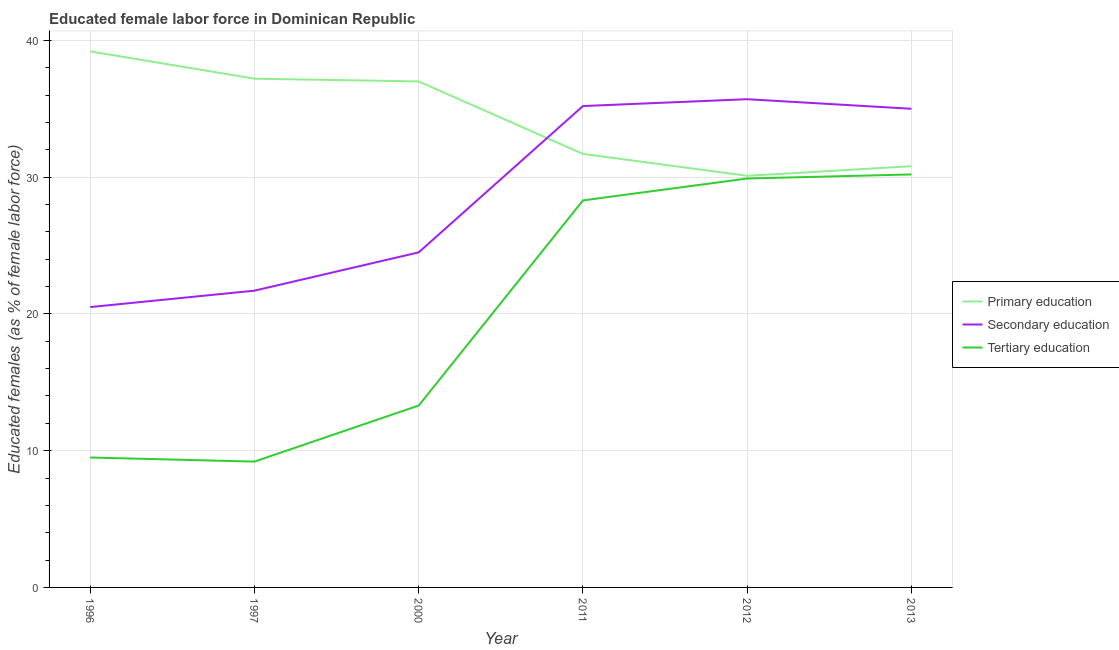How many different coloured lines are there?
Keep it short and to the point. 3. Does the line corresponding to percentage of female labor force who received secondary education intersect with the line corresponding to percentage of female labor force who received tertiary education?
Make the answer very short. No. What is the percentage of female labor force who received primary education in 1996?
Offer a terse response. 39.2. Across all years, what is the maximum percentage of female labor force who received tertiary education?
Make the answer very short. 30.2. Across all years, what is the minimum percentage of female labor force who received tertiary education?
Provide a succinct answer. 9.2. In which year was the percentage of female labor force who received tertiary education maximum?
Make the answer very short. 2013. In which year was the percentage of female labor force who received primary education minimum?
Ensure brevity in your answer.  2012. What is the total percentage of female labor force who received primary education in the graph?
Offer a terse response. 206. What is the difference between the percentage of female labor force who received secondary education in 1997 and that in 2000?
Your response must be concise. -2.8. What is the difference between the percentage of female labor force who received primary education in 2011 and the percentage of female labor force who received tertiary education in 2000?
Provide a succinct answer. 18.4. What is the average percentage of female labor force who received primary education per year?
Your answer should be compact. 34.33. In the year 2011, what is the difference between the percentage of female labor force who received tertiary education and percentage of female labor force who received secondary education?
Provide a short and direct response. -6.9. What is the ratio of the percentage of female labor force who received secondary education in 2011 to that in 2012?
Your answer should be compact. 0.99. Is the percentage of female labor force who received secondary education in 1997 less than that in 2011?
Make the answer very short. Yes. What is the difference between the highest and the second highest percentage of female labor force who received tertiary education?
Ensure brevity in your answer.  0.3. What is the difference between the highest and the lowest percentage of female labor force who received primary education?
Give a very brief answer. 9.1. In how many years, is the percentage of female labor force who received tertiary education greater than the average percentage of female labor force who received tertiary education taken over all years?
Provide a succinct answer. 3. Is the sum of the percentage of female labor force who received tertiary education in 1997 and 2000 greater than the maximum percentage of female labor force who received primary education across all years?
Your answer should be compact. No. Is it the case that in every year, the sum of the percentage of female labor force who received primary education and percentage of female labor force who received secondary education is greater than the percentage of female labor force who received tertiary education?
Give a very brief answer. Yes. Does the percentage of female labor force who received secondary education monotonically increase over the years?
Provide a succinct answer. No. Is the percentage of female labor force who received primary education strictly greater than the percentage of female labor force who received secondary education over the years?
Make the answer very short. No. Is the percentage of female labor force who received primary education strictly less than the percentage of female labor force who received tertiary education over the years?
Your answer should be very brief. No. What is the difference between two consecutive major ticks on the Y-axis?
Offer a terse response. 10. Are the values on the major ticks of Y-axis written in scientific E-notation?
Your response must be concise. No. Where does the legend appear in the graph?
Keep it short and to the point. Center right. What is the title of the graph?
Offer a very short reply. Educated female labor force in Dominican Republic. Does "Domestic" appear as one of the legend labels in the graph?
Give a very brief answer. No. What is the label or title of the Y-axis?
Keep it short and to the point. Educated females (as % of female labor force). What is the Educated females (as % of female labor force) of Primary education in 1996?
Your answer should be very brief. 39.2. What is the Educated females (as % of female labor force) in Primary education in 1997?
Give a very brief answer. 37.2. What is the Educated females (as % of female labor force) of Secondary education in 1997?
Offer a very short reply. 21.7. What is the Educated females (as % of female labor force) in Tertiary education in 1997?
Ensure brevity in your answer.  9.2. What is the Educated females (as % of female labor force) in Secondary education in 2000?
Keep it short and to the point. 24.5. What is the Educated females (as % of female labor force) in Tertiary education in 2000?
Your answer should be very brief. 13.3. What is the Educated females (as % of female labor force) in Primary education in 2011?
Your answer should be very brief. 31.7. What is the Educated females (as % of female labor force) in Secondary education in 2011?
Offer a terse response. 35.2. What is the Educated females (as % of female labor force) in Tertiary education in 2011?
Offer a very short reply. 28.3. What is the Educated females (as % of female labor force) in Primary education in 2012?
Make the answer very short. 30.1. What is the Educated females (as % of female labor force) of Secondary education in 2012?
Offer a very short reply. 35.7. What is the Educated females (as % of female labor force) of Tertiary education in 2012?
Provide a short and direct response. 29.9. What is the Educated females (as % of female labor force) of Primary education in 2013?
Offer a very short reply. 30.8. What is the Educated females (as % of female labor force) in Secondary education in 2013?
Your answer should be very brief. 35. What is the Educated females (as % of female labor force) of Tertiary education in 2013?
Your answer should be compact. 30.2. Across all years, what is the maximum Educated females (as % of female labor force) in Primary education?
Provide a short and direct response. 39.2. Across all years, what is the maximum Educated females (as % of female labor force) in Secondary education?
Offer a terse response. 35.7. Across all years, what is the maximum Educated females (as % of female labor force) in Tertiary education?
Offer a very short reply. 30.2. Across all years, what is the minimum Educated females (as % of female labor force) in Primary education?
Offer a very short reply. 30.1. Across all years, what is the minimum Educated females (as % of female labor force) in Tertiary education?
Provide a succinct answer. 9.2. What is the total Educated females (as % of female labor force) of Primary education in the graph?
Make the answer very short. 206. What is the total Educated females (as % of female labor force) in Secondary education in the graph?
Provide a succinct answer. 172.6. What is the total Educated females (as % of female labor force) of Tertiary education in the graph?
Make the answer very short. 120.4. What is the difference between the Educated females (as % of female labor force) in Primary education in 1996 and that in 1997?
Keep it short and to the point. 2. What is the difference between the Educated females (as % of female labor force) of Secondary education in 1996 and that in 1997?
Provide a succinct answer. -1.2. What is the difference between the Educated females (as % of female labor force) of Primary education in 1996 and that in 2011?
Keep it short and to the point. 7.5. What is the difference between the Educated females (as % of female labor force) of Secondary education in 1996 and that in 2011?
Your answer should be very brief. -14.7. What is the difference between the Educated females (as % of female labor force) of Tertiary education in 1996 and that in 2011?
Provide a succinct answer. -18.8. What is the difference between the Educated females (as % of female labor force) in Secondary education in 1996 and that in 2012?
Offer a terse response. -15.2. What is the difference between the Educated females (as % of female labor force) in Tertiary education in 1996 and that in 2012?
Give a very brief answer. -20.4. What is the difference between the Educated females (as % of female labor force) in Secondary education in 1996 and that in 2013?
Give a very brief answer. -14.5. What is the difference between the Educated females (as % of female labor force) of Tertiary education in 1996 and that in 2013?
Provide a short and direct response. -20.7. What is the difference between the Educated females (as % of female labor force) of Primary education in 1997 and that in 2000?
Provide a short and direct response. 0.2. What is the difference between the Educated females (as % of female labor force) in Secondary education in 1997 and that in 2011?
Provide a short and direct response. -13.5. What is the difference between the Educated females (as % of female labor force) in Tertiary education in 1997 and that in 2011?
Your answer should be compact. -19.1. What is the difference between the Educated females (as % of female labor force) in Secondary education in 1997 and that in 2012?
Offer a very short reply. -14. What is the difference between the Educated females (as % of female labor force) of Tertiary education in 1997 and that in 2012?
Your answer should be very brief. -20.7. What is the difference between the Educated females (as % of female labor force) of Tertiary education in 1997 and that in 2013?
Give a very brief answer. -21. What is the difference between the Educated females (as % of female labor force) in Secondary education in 2000 and that in 2012?
Give a very brief answer. -11.2. What is the difference between the Educated females (as % of female labor force) in Tertiary education in 2000 and that in 2012?
Your answer should be very brief. -16.6. What is the difference between the Educated females (as % of female labor force) in Tertiary education in 2000 and that in 2013?
Provide a short and direct response. -16.9. What is the difference between the Educated females (as % of female labor force) in Secondary education in 2011 and that in 2012?
Your answer should be compact. -0.5. What is the difference between the Educated females (as % of female labor force) in Tertiary education in 2011 and that in 2012?
Provide a short and direct response. -1.6. What is the difference between the Educated females (as % of female labor force) in Tertiary education in 2011 and that in 2013?
Your answer should be compact. -1.9. What is the difference between the Educated females (as % of female labor force) in Primary education in 2012 and that in 2013?
Provide a short and direct response. -0.7. What is the difference between the Educated females (as % of female labor force) in Tertiary education in 2012 and that in 2013?
Provide a succinct answer. -0.3. What is the difference between the Educated females (as % of female labor force) in Primary education in 1996 and the Educated females (as % of female labor force) in Tertiary education in 2000?
Your answer should be compact. 25.9. What is the difference between the Educated females (as % of female labor force) in Secondary education in 1996 and the Educated females (as % of female labor force) in Tertiary education in 2000?
Provide a succinct answer. 7.2. What is the difference between the Educated females (as % of female labor force) of Primary education in 1996 and the Educated females (as % of female labor force) of Secondary education in 2011?
Your answer should be compact. 4. What is the difference between the Educated females (as % of female labor force) in Primary education in 1996 and the Educated females (as % of female labor force) in Tertiary education in 2011?
Make the answer very short. 10.9. What is the difference between the Educated females (as % of female labor force) in Secondary education in 1996 and the Educated females (as % of female labor force) in Tertiary education in 2011?
Give a very brief answer. -7.8. What is the difference between the Educated females (as % of female labor force) of Primary education in 1996 and the Educated females (as % of female labor force) of Secondary education in 2012?
Your response must be concise. 3.5. What is the difference between the Educated females (as % of female labor force) of Primary education in 1996 and the Educated females (as % of female labor force) of Secondary education in 2013?
Your answer should be compact. 4.2. What is the difference between the Educated females (as % of female labor force) of Secondary education in 1996 and the Educated females (as % of female labor force) of Tertiary education in 2013?
Make the answer very short. -9.7. What is the difference between the Educated females (as % of female labor force) of Primary education in 1997 and the Educated females (as % of female labor force) of Tertiary education in 2000?
Ensure brevity in your answer.  23.9. What is the difference between the Educated females (as % of female labor force) in Primary education in 1997 and the Educated females (as % of female labor force) in Secondary education in 2011?
Your response must be concise. 2. What is the difference between the Educated females (as % of female labor force) in Primary education in 1997 and the Educated females (as % of female labor force) in Tertiary education in 2012?
Your answer should be very brief. 7.3. What is the difference between the Educated females (as % of female labor force) of Secondary education in 1997 and the Educated females (as % of female labor force) of Tertiary education in 2012?
Your answer should be very brief. -8.2. What is the difference between the Educated females (as % of female labor force) in Primary education in 1997 and the Educated females (as % of female labor force) in Secondary education in 2013?
Offer a very short reply. 2.2. What is the difference between the Educated females (as % of female labor force) in Primary education in 1997 and the Educated females (as % of female labor force) in Tertiary education in 2013?
Keep it short and to the point. 7. What is the difference between the Educated females (as % of female labor force) of Primary education in 2000 and the Educated females (as % of female labor force) of Secondary education in 2012?
Offer a terse response. 1.3. What is the difference between the Educated females (as % of female labor force) of Primary education in 2000 and the Educated females (as % of female labor force) of Tertiary education in 2012?
Your answer should be very brief. 7.1. What is the difference between the Educated females (as % of female labor force) in Primary education in 2000 and the Educated females (as % of female labor force) in Secondary education in 2013?
Give a very brief answer. 2. What is the difference between the Educated females (as % of female labor force) of Secondary education in 2000 and the Educated females (as % of female labor force) of Tertiary education in 2013?
Offer a terse response. -5.7. What is the difference between the Educated females (as % of female labor force) of Primary education in 2011 and the Educated females (as % of female labor force) of Tertiary education in 2012?
Your response must be concise. 1.8. What is the difference between the Educated females (as % of female labor force) in Primary education in 2011 and the Educated females (as % of female labor force) in Secondary education in 2013?
Offer a very short reply. -3.3. What is the difference between the Educated females (as % of female labor force) in Primary education in 2011 and the Educated females (as % of female labor force) in Tertiary education in 2013?
Your answer should be very brief. 1.5. What is the difference between the Educated females (as % of female labor force) in Secondary education in 2011 and the Educated females (as % of female labor force) in Tertiary education in 2013?
Your answer should be very brief. 5. What is the difference between the Educated females (as % of female labor force) in Primary education in 2012 and the Educated females (as % of female labor force) in Secondary education in 2013?
Your response must be concise. -4.9. What is the difference between the Educated females (as % of female labor force) of Primary education in 2012 and the Educated females (as % of female labor force) of Tertiary education in 2013?
Your answer should be very brief. -0.1. What is the difference between the Educated females (as % of female labor force) in Secondary education in 2012 and the Educated females (as % of female labor force) in Tertiary education in 2013?
Your response must be concise. 5.5. What is the average Educated females (as % of female labor force) in Primary education per year?
Provide a short and direct response. 34.33. What is the average Educated females (as % of female labor force) in Secondary education per year?
Your answer should be very brief. 28.77. What is the average Educated females (as % of female labor force) in Tertiary education per year?
Offer a terse response. 20.07. In the year 1996, what is the difference between the Educated females (as % of female labor force) of Primary education and Educated females (as % of female labor force) of Tertiary education?
Give a very brief answer. 29.7. In the year 1997, what is the difference between the Educated females (as % of female labor force) of Primary education and Educated females (as % of female labor force) of Secondary education?
Offer a terse response. 15.5. In the year 1997, what is the difference between the Educated females (as % of female labor force) in Primary education and Educated females (as % of female labor force) in Tertiary education?
Your answer should be compact. 28. In the year 2000, what is the difference between the Educated females (as % of female labor force) in Primary education and Educated females (as % of female labor force) in Tertiary education?
Keep it short and to the point. 23.7. In the year 2011, what is the difference between the Educated females (as % of female labor force) in Primary education and Educated females (as % of female labor force) in Secondary education?
Ensure brevity in your answer.  -3.5. In the year 2011, what is the difference between the Educated females (as % of female labor force) in Primary education and Educated females (as % of female labor force) in Tertiary education?
Your answer should be compact. 3.4. In the year 2012, what is the difference between the Educated females (as % of female labor force) of Primary education and Educated females (as % of female labor force) of Secondary education?
Provide a succinct answer. -5.6. In the year 2012, what is the difference between the Educated females (as % of female labor force) of Primary education and Educated females (as % of female labor force) of Tertiary education?
Provide a succinct answer. 0.2. In the year 2012, what is the difference between the Educated females (as % of female labor force) of Secondary education and Educated females (as % of female labor force) of Tertiary education?
Make the answer very short. 5.8. In the year 2013, what is the difference between the Educated females (as % of female labor force) in Primary education and Educated females (as % of female labor force) in Secondary education?
Keep it short and to the point. -4.2. In the year 2013, what is the difference between the Educated females (as % of female labor force) of Primary education and Educated females (as % of female labor force) of Tertiary education?
Give a very brief answer. 0.6. What is the ratio of the Educated females (as % of female labor force) in Primary education in 1996 to that in 1997?
Your answer should be compact. 1.05. What is the ratio of the Educated females (as % of female labor force) of Secondary education in 1996 to that in 1997?
Keep it short and to the point. 0.94. What is the ratio of the Educated females (as % of female labor force) of Tertiary education in 1996 to that in 1997?
Your answer should be compact. 1.03. What is the ratio of the Educated females (as % of female labor force) in Primary education in 1996 to that in 2000?
Your response must be concise. 1.06. What is the ratio of the Educated females (as % of female labor force) in Secondary education in 1996 to that in 2000?
Your response must be concise. 0.84. What is the ratio of the Educated females (as % of female labor force) of Tertiary education in 1996 to that in 2000?
Give a very brief answer. 0.71. What is the ratio of the Educated females (as % of female labor force) of Primary education in 1996 to that in 2011?
Ensure brevity in your answer.  1.24. What is the ratio of the Educated females (as % of female labor force) of Secondary education in 1996 to that in 2011?
Keep it short and to the point. 0.58. What is the ratio of the Educated females (as % of female labor force) in Tertiary education in 1996 to that in 2011?
Ensure brevity in your answer.  0.34. What is the ratio of the Educated females (as % of female labor force) in Primary education in 1996 to that in 2012?
Keep it short and to the point. 1.3. What is the ratio of the Educated females (as % of female labor force) in Secondary education in 1996 to that in 2012?
Provide a succinct answer. 0.57. What is the ratio of the Educated females (as % of female labor force) of Tertiary education in 1996 to that in 2012?
Your answer should be very brief. 0.32. What is the ratio of the Educated females (as % of female labor force) of Primary education in 1996 to that in 2013?
Your response must be concise. 1.27. What is the ratio of the Educated females (as % of female labor force) of Secondary education in 1996 to that in 2013?
Offer a very short reply. 0.59. What is the ratio of the Educated females (as % of female labor force) of Tertiary education in 1996 to that in 2013?
Provide a succinct answer. 0.31. What is the ratio of the Educated females (as % of female labor force) of Primary education in 1997 to that in 2000?
Offer a very short reply. 1.01. What is the ratio of the Educated females (as % of female labor force) of Secondary education in 1997 to that in 2000?
Offer a very short reply. 0.89. What is the ratio of the Educated females (as % of female labor force) of Tertiary education in 1997 to that in 2000?
Make the answer very short. 0.69. What is the ratio of the Educated females (as % of female labor force) in Primary education in 1997 to that in 2011?
Offer a terse response. 1.17. What is the ratio of the Educated females (as % of female labor force) of Secondary education in 1997 to that in 2011?
Ensure brevity in your answer.  0.62. What is the ratio of the Educated females (as % of female labor force) in Tertiary education in 1997 to that in 2011?
Your answer should be compact. 0.33. What is the ratio of the Educated females (as % of female labor force) in Primary education in 1997 to that in 2012?
Give a very brief answer. 1.24. What is the ratio of the Educated females (as % of female labor force) in Secondary education in 1997 to that in 2012?
Your response must be concise. 0.61. What is the ratio of the Educated females (as % of female labor force) in Tertiary education in 1997 to that in 2012?
Provide a short and direct response. 0.31. What is the ratio of the Educated females (as % of female labor force) of Primary education in 1997 to that in 2013?
Keep it short and to the point. 1.21. What is the ratio of the Educated females (as % of female labor force) in Secondary education in 1997 to that in 2013?
Your answer should be compact. 0.62. What is the ratio of the Educated females (as % of female labor force) in Tertiary education in 1997 to that in 2013?
Provide a short and direct response. 0.3. What is the ratio of the Educated females (as % of female labor force) in Primary education in 2000 to that in 2011?
Ensure brevity in your answer.  1.17. What is the ratio of the Educated females (as % of female labor force) in Secondary education in 2000 to that in 2011?
Your response must be concise. 0.7. What is the ratio of the Educated females (as % of female labor force) of Tertiary education in 2000 to that in 2011?
Your answer should be compact. 0.47. What is the ratio of the Educated females (as % of female labor force) of Primary education in 2000 to that in 2012?
Offer a terse response. 1.23. What is the ratio of the Educated females (as % of female labor force) in Secondary education in 2000 to that in 2012?
Provide a succinct answer. 0.69. What is the ratio of the Educated females (as % of female labor force) in Tertiary education in 2000 to that in 2012?
Provide a short and direct response. 0.44. What is the ratio of the Educated females (as % of female labor force) of Primary education in 2000 to that in 2013?
Provide a succinct answer. 1.2. What is the ratio of the Educated females (as % of female labor force) of Tertiary education in 2000 to that in 2013?
Offer a terse response. 0.44. What is the ratio of the Educated females (as % of female labor force) in Primary education in 2011 to that in 2012?
Make the answer very short. 1.05. What is the ratio of the Educated females (as % of female labor force) in Secondary education in 2011 to that in 2012?
Keep it short and to the point. 0.99. What is the ratio of the Educated females (as % of female labor force) of Tertiary education in 2011 to that in 2012?
Your answer should be compact. 0.95. What is the ratio of the Educated females (as % of female labor force) of Primary education in 2011 to that in 2013?
Provide a short and direct response. 1.03. What is the ratio of the Educated females (as % of female labor force) of Secondary education in 2011 to that in 2013?
Your response must be concise. 1.01. What is the ratio of the Educated females (as % of female labor force) in Tertiary education in 2011 to that in 2013?
Provide a succinct answer. 0.94. What is the ratio of the Educated females (as % of female labor force) of Primary education in 2012 to that in 2013?
Offer a terse response. 0.98. What is the ratio of the Educated females (as % of female labor force) in Secondary education in 2012 to that in 2013?
Keep it short and to the point. 1.02. What is the difference between the highest and the second highest Educated females (as % of female labor force) of Primary education?
Offer a terse response. 2. What is the difference between the highest and the second highest Educated females (as % of female labor force) in Secondary education?
Provide a short and direct response. 0.5. What is the difference between the highest and the lowest Educated females (as % of female labor force) in Secondary education?
Ensure brevity in your answer.  15.2. 